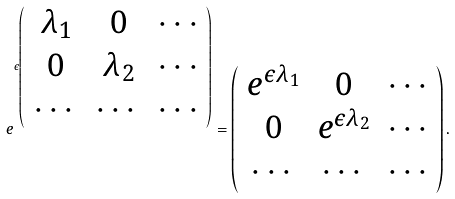<formula> <loc_0><loc_0><loc_500><loc_500>e ^ { \epsilon \left ( \begin{array} { c c c } \lambda _ { 1 } & 0 & \cdots \\ 0 & \lambda _ { 2 } & \cdots \\ \cdots & \cdots & \cdots \end{array} \right ) } = \left ( \begin{array} { c c c } e ^ { \epsilon \lambda _ { 1 } } & 0 & \cdots \\ 0 & e ^ { \epsilon \lambda _ { 2 } } & \cdots \\ \cdots & \cdots & \cdots \end{array} \right ) .</formula> 